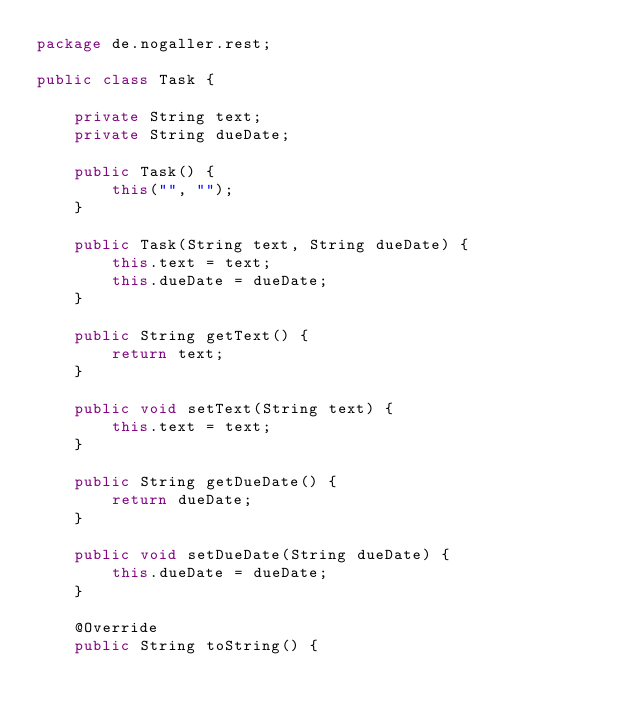<code> <loc_0><loc_0><loc_500><loc_500><_Java_>package de.nogaller.rest;

public class Task {

	private String text;
	private String dueDate;

	public Task() {
		this("", "");
	}

	public Task(String text, String dueDate) {
		this.text = text;
		this.dueDate = dueDate;
	}

	public String getText() {
		return text;
	}

	public void setText(String text) {
		this.text = text;
	}

	public String getDueDate() {
		return dueDate;
	}

	public void setDueDate(String dueDate) {
		this.dueDate = dueDate;
	}

	@Override
	public String toString() {</code> 